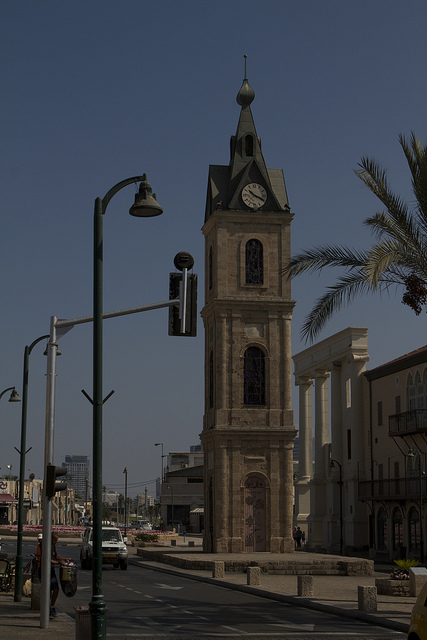<image>What number is on the street? The number on the street is unclear. It could be any number. What kind of car is the little white one? I don't know what kind of car the little white one is. It could be a jeep, sedan, kia, compact, volvo, or ford. Where is Jamba Juice? It is unknown where Jamba Juice is located. It is not pictured. In which city was this photo taken? I don't know in which city this photo was taken. It could be Houston, St Augustine, London, Tampa, Albuquerque, or Miami. Is it cold here? It is unanswerable whether it is cold here. What number is on the street? I am not sure what number is on the street. But it can be seen '0', '12' or '1'. What kind of car is the little white one? I don't know what kind of car the little white one is. It could be a jeep, sedan, kia, compact, volvo or ford. Where is Jamba Juice? It is unknown where Jamba Juice is located. It is not pictured in the image. In which city was this photo taken? I don't know in which city this photo was taken. It can be either Houston, St Augustine, London, Tropical, Tampa, Albuquerque or Miami. Is it cold here? It is not cold here. 